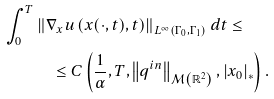<formula> <loc_0><loc_0><loc_500><loc_500>\int _ { 0 } ^ { T } & \left \| \nabla _ { x } u \left ( x ( \cdot , t ) , t \right ) \right \| _ { L ^ { \infty } \left ( \Gamma _ { 0 } , \Gamma _ { 1 } \right ) } d t \leq \\ & \quad \leq C \left ( \frac { 1 } { \alpha } , T , \left \| q ^ { i n } \right \| _ { \mathcal { M } \left ( \mathbb { R } ^ { 2 } \right ) } , \left | x _ { 0 } \right | _ { \ast } \right ) .</formula> 